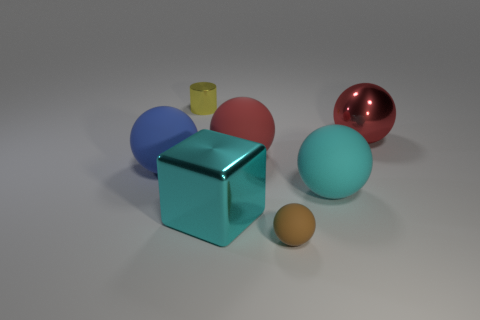Subtract all yellow cylinders. How many red balls are left? 2 Add 2 big red metallic objects. How many objects exist? 9 Subtract all small balls. How many balls are left? 4 Subtract all brown balls. How many balls are left? 4 Subtract all green blocks. Subtract all yellow cylinders. How many blocks are left? 1 Subtract all tiny cylinders. Subtract all large metallic things. How many objects are left? 4 Add 1 blue spheres. How many blue spheres are left? 2 Add 4 brown things. How many brown things exist? 5 Subtract 0 blue cubes. How many objects are left? 7 Subtract all blocks. How many objects are left? 6 